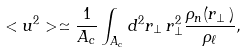<formula> <loc_0><loc_0><loc_500><loc_500>< u ^ { 2 } > \simeq \frac { 1 } { A _ { c } } \int _ { A _ { c } } d ^ { 2 } r _ { \perp } \, r _ { \perp } ^ { 2 } \frac { \rho _ { n } ( { r } _ { \perp } \, ) } { \rho _ { \ell } } ,</formula> 